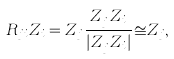Convert formula to latex. <formula><loc_0><loc_0><loc_500><loc_500>R _ { j i } Z _ { i } = Z _ { j } \frac { Z _ { j } ^ { \dag } Z _ { i } } { | Z _ { j } ^ { \dag } Z _ { i } | } \cong Z _ { j } ,</formula> 